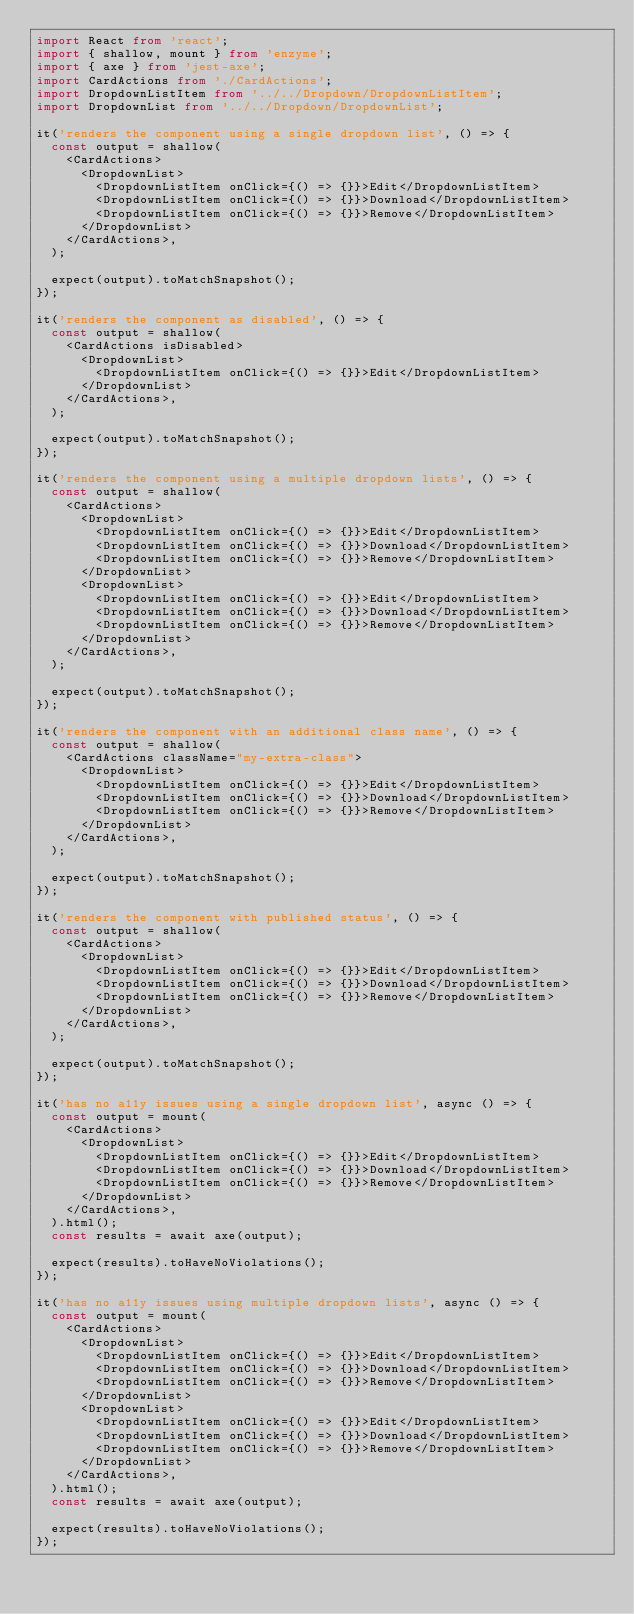Convert code to text. <code><loc_0><loc_0><loc_500><loc_500><_TypeScript_>import React from 'react';
import { shallow, mount } from 'enzyme';
import { axe } from 'jest-axe';
import CardActions from './CardActions';
import DropdownListItem from '../../Dropdown/DropdownListItem';
import DropdownList from '../../Dropdown/DropdownList';

it('renders the component using a single dropdown list', () => {
  const output = shallow(
    <CardActions>
      <DropdownList>
        <DropdownListItem onClick={() => {}}>Edit</DropdownListItem>
        <DropdownListItem onClick={() => {}}>Download</DropdownListItem>
        <DropdownListItem onClick={() => {}}>Remove</DropdownListItem>
      </DropdownList>
    </CardActions>,
  );

  expect(output).toMatchSnapshot();
});

it('renders the component as disabled', () => {
  const output = shallow(
    <CardActions isDisabled>
      <DropdownList>
        <DropdownListItem onClick={() => {}}>Edit</DropdownListItem>
      </DropdownList>
    </CardActions>,
  );

  expect(output).toMatchSnapshot();
});

it('renders the component using a multiple dropdown lists', () => {
  const output = shallow(
    <CardActions>
      <DropdownList>
        <DropdownListItem onClick={() => {}}>Edit</DropdownListItem>
        <DropdownListItem onClick={() => {}}>Download</DropdownListItem>
        <DropdownListItem onClick={() => {}}>Remove</DropdownListItem>
      </DropdownList>
      <DropdownList>
        <DropdownListItem onClick={() => {}}>Edit</DropdownListItem>
        <DropdownListItem onClick={() => {}}>Download</DropdownListItem>
        <DropdownListItem onClick={() => {}}>Remove</DropdownListItem>
      </DropdownList>
    </CardActions>,
  );

  expect(output).toMatchSnapshot();
});

it('renders the component with an additional class name', () => {
  const output = shallow(
    <CardActions className="my-extra-class">
      <DropdownList>
        <DropdownListItem onClick={() => {}}>Edit</DropdownListItem>
        <DropdownListItem onClick={() => {}}>Download</DropdownListItem>
        <DropdownListItem onClick={() => {}}>Remove</DropdownListItem>
      </DropdownList>
    </CardActions>,
  );

  expect(output).toMatchSnapshot();
});

it('renders the component with published status', () => {
  const output = shallow(
    <CardActions>
      <DropdownList>
        <DropdownListItem onClick={() => {}}>Edit</DropdownListItem>
        <DropdownListItem onClick={() => {}}>Download</DropdownListItem>
        <DropdownListItem onClick={() => {}}>Remove</DropdownListItem>
      </DropdownList>
    </CardActions>,
  );

  expect(output).toMatchSnapshot();
});

it('has no a11y issues using a single dropdown list', async () => {
  const output = mount(
    <CardActions>
      <DropdownList>
        <DropdownListItem onClick={() => {}}>Edit</DropdownListItem>
        <DropdownListItem onClick={() => {}}>Download</DropdownListItem>
        <DropdownListItem onClick={() => {}}>Remove</DropdownListItem>
      </DropdownList>
    </CardActions>,
  ).html();
  const results = await axe(output);

  expect(results).toHaveNoViolations();
});

it('has no a11y issues using multiple dropdown lists', async () => {
  const output = mount(
    <CardActions>
      <DropdownList>
        <DropdownListItem onClick={() => {}}>Edit</DropdownListItem>
        <DropdownListItem onClick={() => {}}>Download</DropdownListItem>
        <DropdownListItem onClick={() => {}}>Remove</DropdownListItem>
      </DropdownList>
      <DropdownList>
        <DropdownListItem onClick={() => {}}>Edit</DropdownListItem>
        <DropdownListItem onClick={() => {}}>Download</DropdownListItem>
        <DropdownListItem onClick={() => {}}>Remove</DropdownListItem>
      </DropdownList>
    </CardActions>,
  ).html();
  const results = await axe(output);

  expect(results).toHaveNoViolations();
});
</code> 